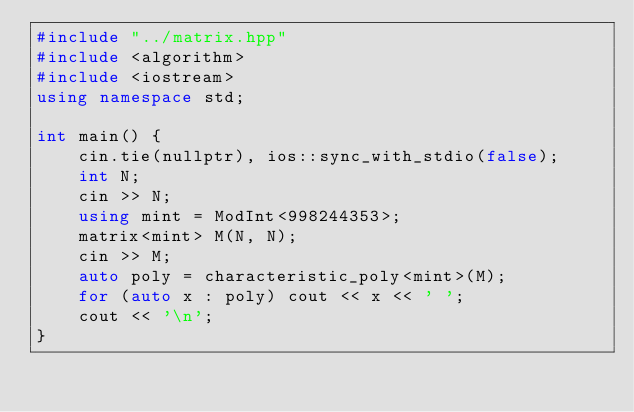<code> <loc_0><loc_0><loc_500><loc_500><_C++_>#include "../matrix.hpp"
#include <algorithm>
#include <iostream>
using namespace std;

int main() {
    cin.tie(nullptr), ios::sync_with_stdio(false);
    int N;
    cin >> N;
    using mint = ModInt<998244353>;
    matrix<mint> M(N, N);
    cin >> M;
    auto poly = characteristic_poly<mint>(M);
    for (auto x : poly) cout << x << ' ';
    cout << '\n';
}
</code> 